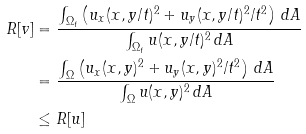Convert formula to latex. <formula><loc_0><loc_0><loc_500><loc_500>R [ v ] & = \frac { \int _ { \Omega _ { t } } \left ( u _ { x } ( x , y / t ) ^ { 2 } + u _ { y } ( x , y / t ) ^ { 2 } / t ^ { 2 } \right ) \, d A } { \int _ { \Omega _ { t } } u ( x , y / t ) ^ { 2 } \, d A } \\ & = \frac { \int _ { \Omega } \left ( u _ { x } ( x , y ) ^ { 2 } + u _ { y } ( x , y ) ^ { 2 } / t ^ { 2 } \right ) \, d A } { \int _ { \Omega } u ( x , y ) ^ { 2 } \, d A } \\ & \leq R [ u ]</formula> 